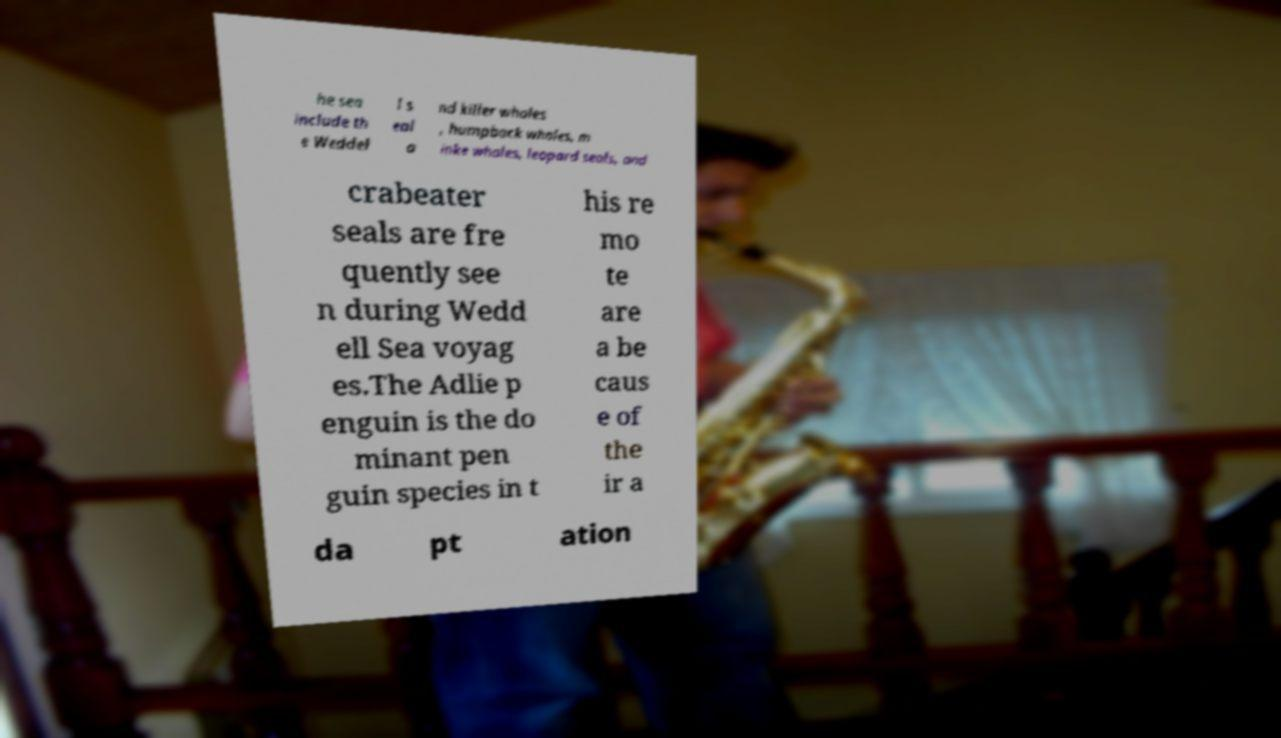Could you extract and type out the text from this image? he sea include th e Weddel l s eal a nd killer whales , humpback whales, m inke whales, leopard seals, and crabeater seals are fre quently see n during Wedd ell Sea voyag es.The Adlie p enguin is the do minant pen guin species in t his re mo te are a be caus e of the ir a da pt ation 